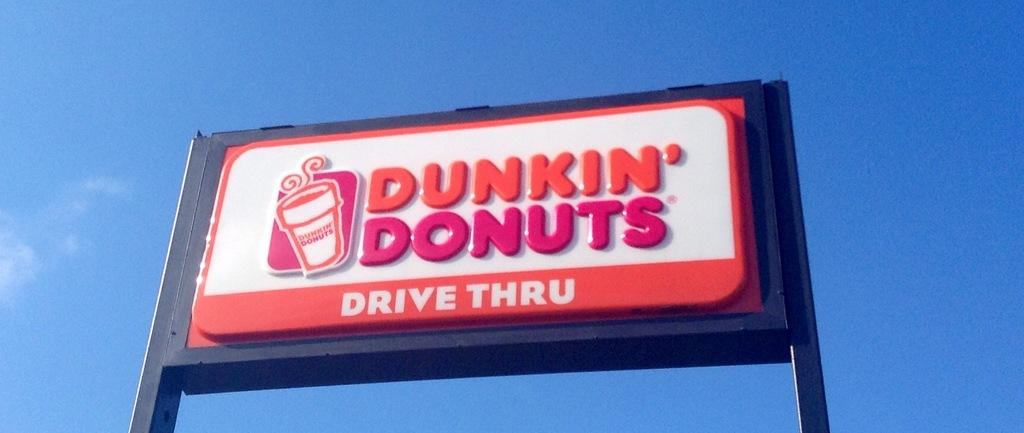Provide a one-sentence caption for the provided image. A Dunkin' Donuts Drive Thru sign is set against a blue sky. 